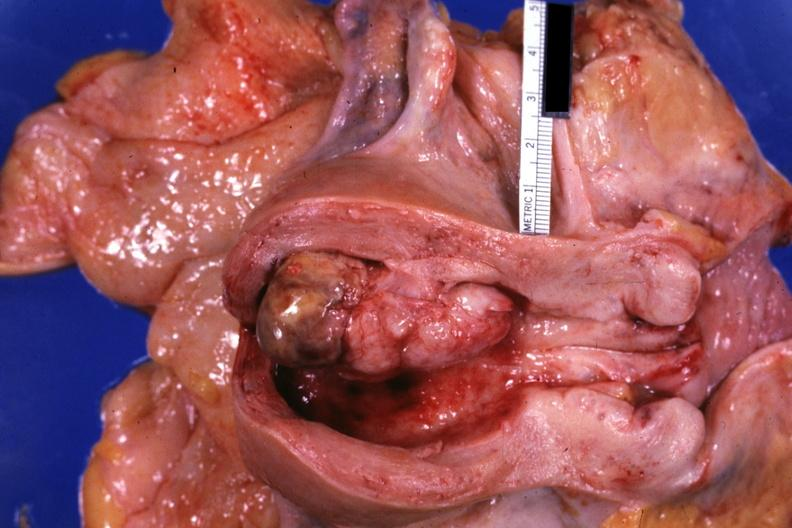s this opened uterus shows tumor?
Answer the question using a single word or phrase. Yes 